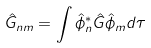Convert formula to latex. <formula><loc_0><loc_0><loc_500><loc_500>\hat { G } _ { n m } = \int \hat { \phi } _ { n } ^ { * } \hat { G } \hat { \phi } _ { m } d \tau</formula> 